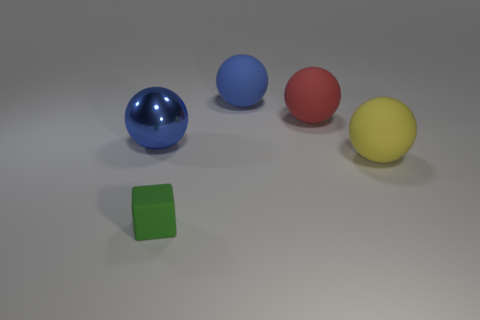What number of things are green shiny things or green rubber blocks?
Provide a succinct answer. 1. There is a blue ball that is behind the big blue metal thing; does it have the same size as the blue thing that is to the left of the big blue matte thing?
Your response must be concise. Yes. What number of other objects are the same material as the cube?
Your answer should be very brief. 3. Are there more big blue balls behind the large blue metal thing than blocks in front of the small green object?
Your answer should be compact. Yes. What material is the blue ball on the left side of the small cube?
Provide a succinct answer. Metal. Is the shape of the yellow rubber thing the same as the large red thing?
Make the answer very short. Yes. Is there anything else of the same color as the small cube?
Provide a succinct answer. No. Are there more small green objects that are on the left side of the green matte block than big spheres?
Offer a terse response. No. What color is the large matte ball in front of the large red rubber ball?
Keep it short and to the point. Yellow. Does the yellow rubber thing have the same size as the red matte thing?
Keep it short and to the point. Yes. 